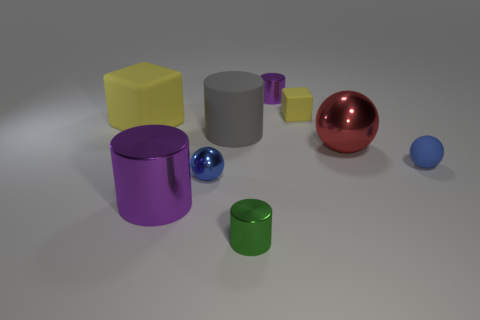Subtract 1 cylinders. How many cylinders are left? 3 Add 1 big purple shiny cylinders. How many objects exist? 10 Subtract all cylinders. How many objects are left? 5 Subtract 0 purple spheres. How many objects are left? 9 Subtract all large red shiny balls. Subtract all large rubber cubes. How many objects are left? 7 Add 6 big purple objects. How many big purple objects are left? 7 Add 2 big rubber things. How many big rubber things exist? 4 